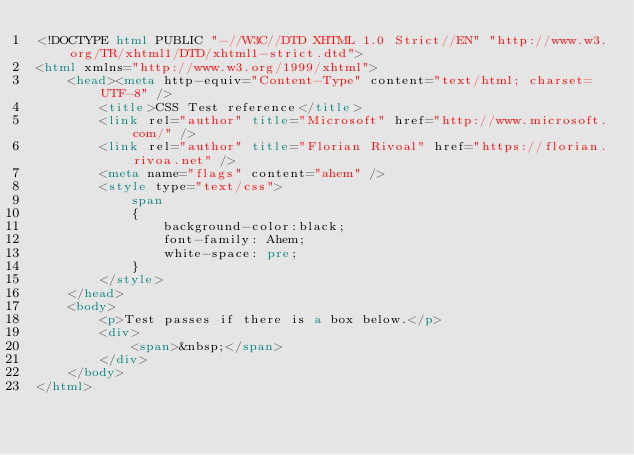Convert code to text. <code><loc_0><loc_0><loc_500><loc_500><_HTML_><!DOCTYPE html PUBLIC "-//W3C//DTD XHTML 1.0 Strict//EN" "http://www.w3.org/TR/xhtml1/DTD/xhtml1-strict.dtd">
<html xmlns="http://www.w3.org/1999/xhtml">
    <head><meta http-equiv="Content-Type" content="text/html; charset=UTF-8" />
        <title>CSS Test reference</title>
        <link rel="author" title="Microsoft" href="http://www.microsoft.com/" />
        <link rel="author" title="Florian Rivoal" href="https://florian.rivoa.net" />
        <meta name="flags" content="ahem" />
        <style type="text/css">
            span
            {
                background-color:black;
                font-family: Ahem;
                white-space: pre;
            }
        </style>
    </head>
    <body>
        <p>Test passes if there is a box below.</p>
        <div>
            <span>&nbsp;</span>
        </div>
    </body>
</html></code> 